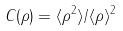Convert formula to latex. <formula><loc_0><loc_0><loc_500><loc_500>C ( \rho ) = \langle \rho ^ { 2 } \rangle / \langle \rho \rangle ^ { 2 }</formula> 